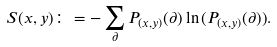Convert formula to latex. <formula><loc_0><loc_0><loc_500><loc_500>S ( x , y ) \colon = - \sum _ { \partial } P _ { ( x , y ) } ( \partial ) \ln { ( P _ { ( x , y ) } ( \partial ) ) } .</formula> 